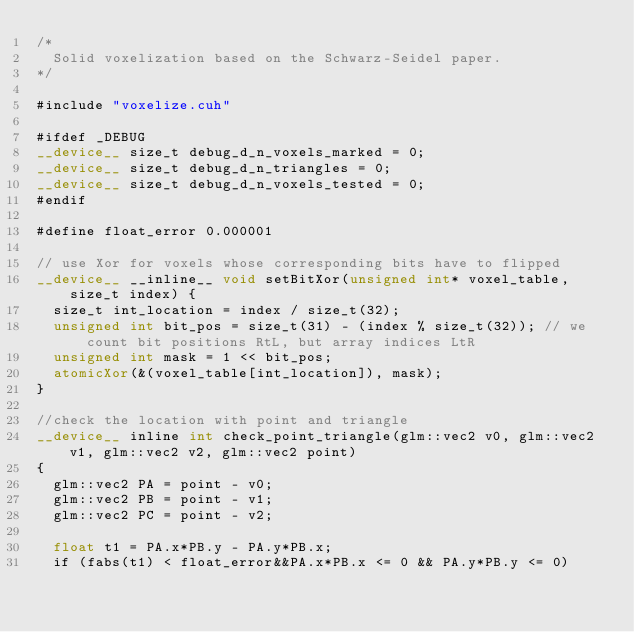Convert code to text. <code><loc_0><loc_0><loc_500><loc_500><_Cuda_>/*
	Solid voxelization based on the Schwarz-Seidel paper.
*/

#include "voxelize.cuh"

#ifdef _DEBUG
__device__ size_t debug_d_n_voxels_marked = 0;
__device__ size_t debug_d_n_triangles = 0;
__device__ size_t debug_d_n_voxels_tested = 0;
#endif

#define float_error 0.000001

// use Xor for voxels whose corresponding bits have to flipped
__device__ __inline__ void setBitXor(unsigned int* voxel_table, size_t index) {
	size_t int_location = index / size_t(32);
	unsigned int bit_pos = size_t(31) - (index % size_t(32)); // we count bit positions RtL, but array indices LtR
	unsigned int mask = 1 << bit_pos;
	atomicXor(&(voxel_table[int_location]), mask);
}

//check the location with point and triangle
__device__ inline int check_point_triangle(glm::vec2 v0, glm::vec2 v1, glm::vec2 v2, glm::vec2 point)
{
	glm::vec2 PA = point - v0;
	glm::vec2 PB = point - v1;
	glm::vec2 PC = point - v2;

	float t1 = PA.x*PB.y - PA.y*PB.x;
	if (fabs(t1) < float_error&&PA.x*PB.x <= 0 && PA.y*PB.y <= 0)</code> 